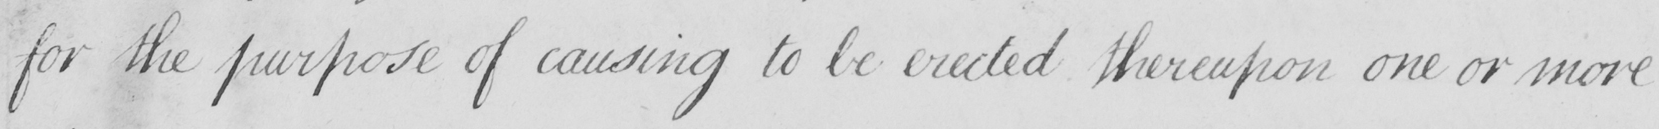What does this handwritten line say? for the purpose of causing to be erected thereupon one or more 